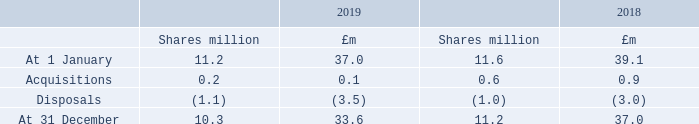29 Employee Share Ownership Plan (ESOP)
The cost of shares in intu properties plc held by the Trustee of the ESOP operated by the Company is accounted for as a deduction from equity.
The purpose of the ESOP is to acquire and hold shares which will be transferred to employees in the future under the Group’s employee incentive arrangements as described in note 7 including joint ownership of shares in its role as Trustee of the Joint Share Ownership Plan. During 2019, no dividends in respect of these shares have been waived by agreement (2018: £1.6 million).
What were the dividends in respect of these shares have been waived by agreement in 2018? £1.6 million. What is the purpose of the ESOP? To acquire and hold shares which will be transferred to employees in the future under the group’s employee incentive arrangements. How are the cost of shares in intu properties plc held by the Trustee of the ESOP operated by the Company accounted for? Accounted for as a deduction from equity. What is the percentage change in the acquisitions value from 2018 to 2019?
Answer scale should be: percent. (0.1-0.9)/0.9
Answer: -88.89. What is the percentage change in the disposals value from 2018 to 2019?
Answer scale should be: percent. (3.5-3.0)/3.0
Answer: 16.67. What is the percentage change in the shares from 31 December 2018 to 31 December 2019?
Answer scale should be: percent. (10.3-11.2)/11.2
Answer: -8.04. 